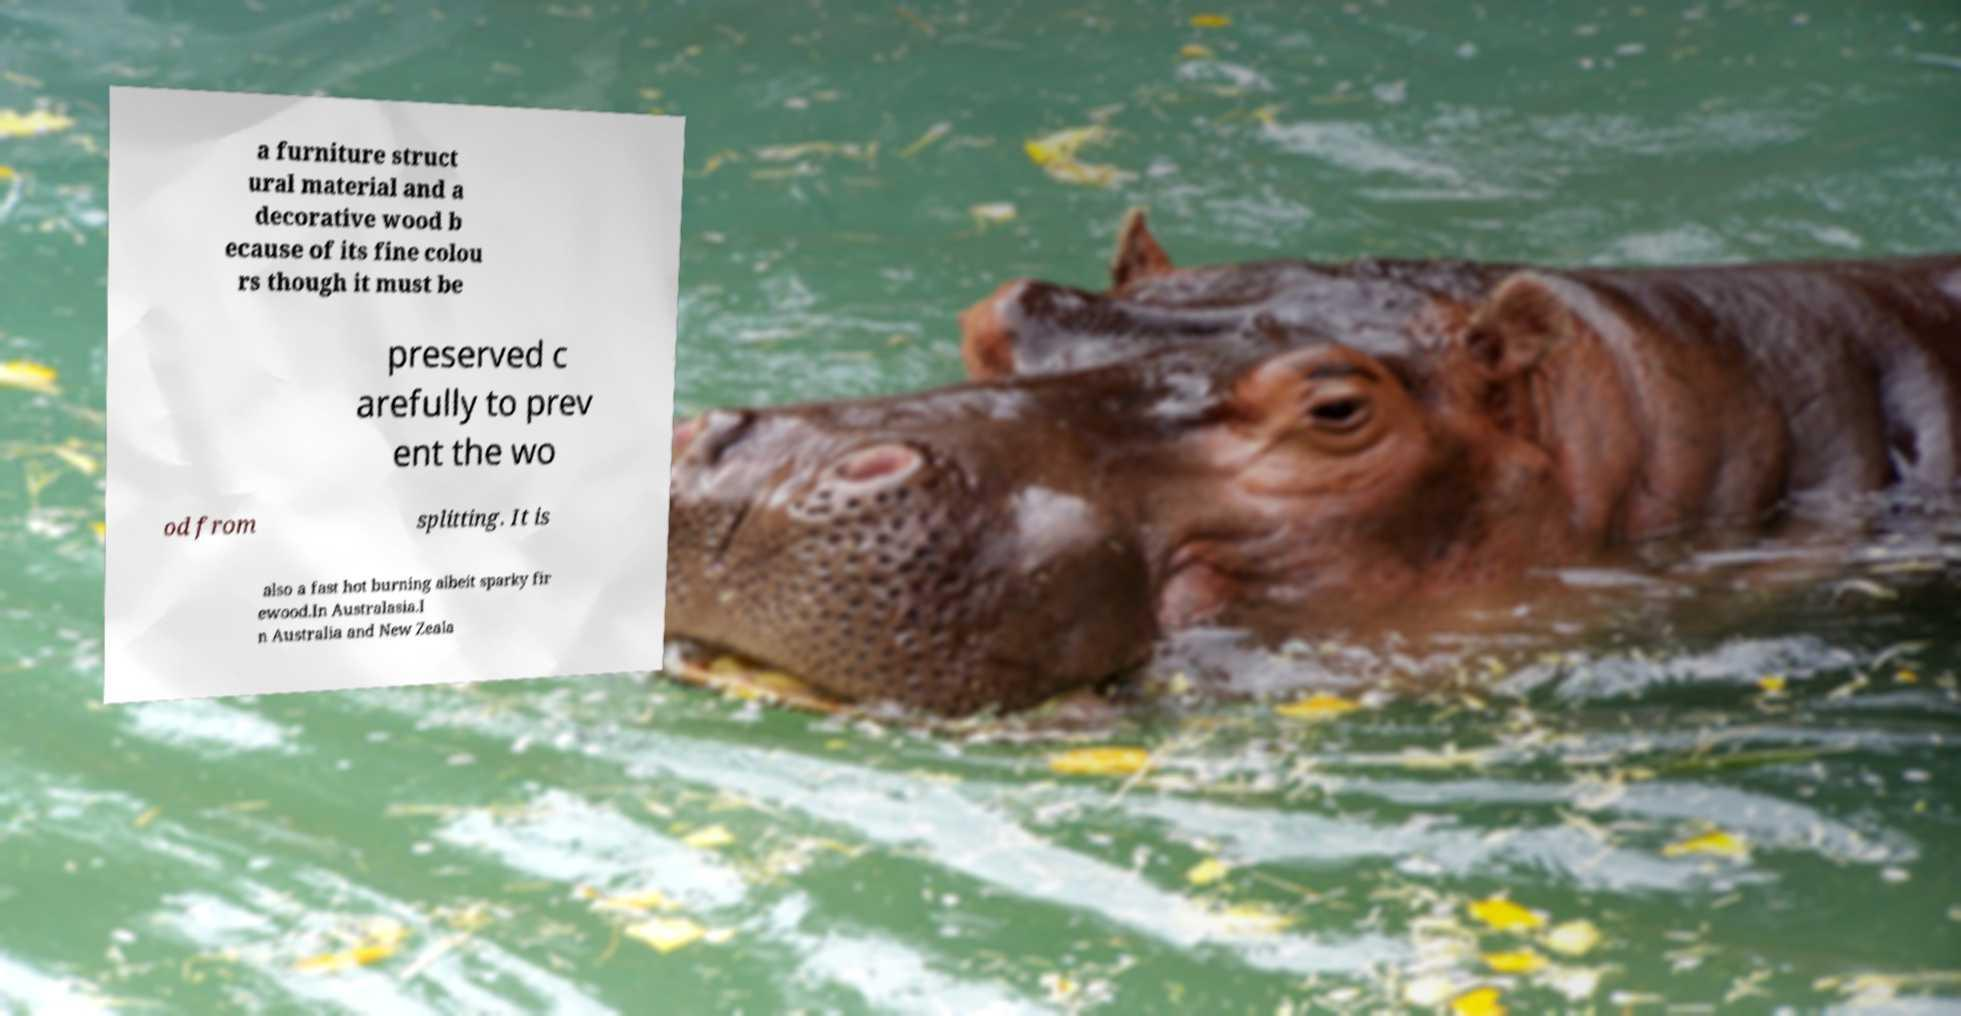What messages or text are displayed in this image? I need them in a readable, typed format. a furniture struct ural material and a decorative wood b ecause of its fine colou rs though it must be preserved c arefully to prev ent the wo od from splitting. It is also a fast hot burning albeit sparky fir ewood.In Australasia.I n Australia and New Zeala 